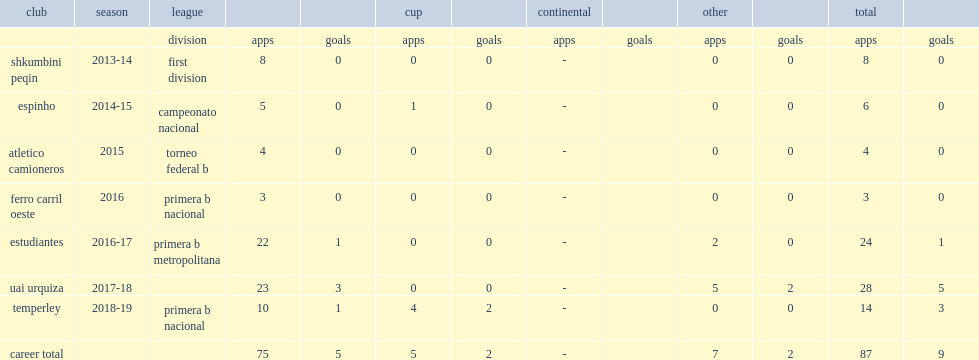Which club did mazur play for in 2015? Atletico camioneros. 